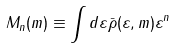Convert formula to latex. <formula><loc_0><loc_0><loc_500><loc_500>M _ { n } ( m ) \equiv \int d \varepsilon \bar { \rho } ( \varepsilon , m ) \varepsilon ^ { n }</formula> 